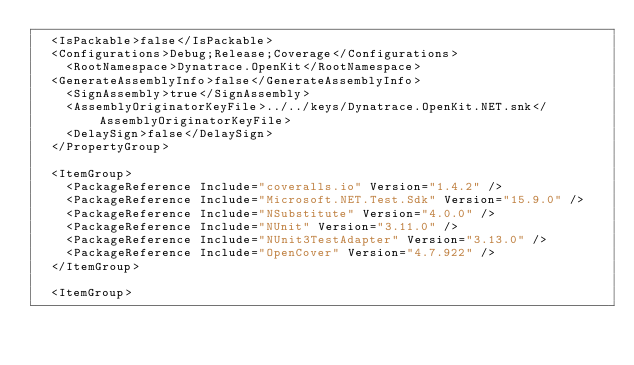Convert code to text. <code><loc_0><loc_0><loc_500><loc_500><_XML_>	<IsPackable>false</IsPackable>
	<Configurations>Debug;Release;Coverage</Configurations>
    <RootNamespace>Dynatrace.OpenKit</RootNamespace>
	<GenerateAssemblyInfo>false</GenerateAssemblyInfo>
    <SignAssembly>true</SignAssembly>
    <AssemblyOriginatorKeyFile>../../keys/Dynatrace.OpenKit.NET.snk</AssemblyOriginatorKeyFile>
    <DelaySign>false</DelaySign>
  </PropertyGroup>
  
  <ItemGroup>
    <PackageReference Include="coveralls.io" Version="1.4.2" />
    <PackageReference Include="Microsoft.NET.Test.Sdk" Version="15.9.0" />
    <PackageReference Include="NSubstitute" Version="4.0.0" />
    <PackageReference Include="NUnit" Version="3.11.0" />
    <PackageReference Include="NUnit3TestAdapter" Version="3.13.0" />
    <PackageReference Include="OpenCover" Version="4.7.922" />
  </ItemGroup>
  
  <ItemGroup></code> 